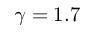<formula> <loc_0><loc_0><loc_500><loc_500>\gamma = 1 . 7</formula> 